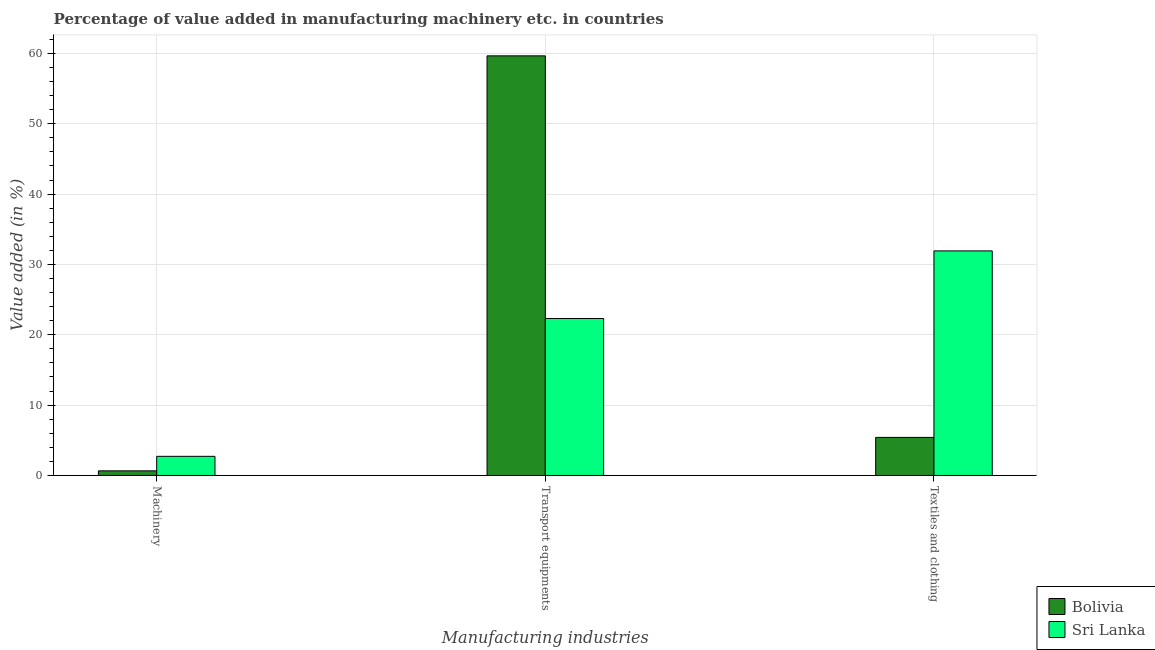How many groups of bars are there?
Your answer should be very brief. 3. Are the number of bars per tick equal to the number of legend labels?
Keep it short and to the point. Yes. How many bars are there on the 2nd tick from the left?
Your response must be concise. 2. What is the label of the 3rd group of bars from the left?
Give a very brief answer. Textiles and clothing. What is the value added in manufacturing transport equipments in Bolivia?
Provide a short and direct response. 59.66. Across all countries, what is the maximum value added in manufacturing transport equipments?
Ensure brevity in your answer.  59.66. Across all countries, what is the minimum value added in manufacturing textile and clothing?
Your answer should be compact. 5.41. In which country was the value added in manufacturing transport equipments minimum?
Offer a terse response. Sri Lanka. What is the total value added in manufacturing machinery in the graph?
Offer a very short reply. 3.37. What is the difference between the value added in manufacturing machinery in Sri Lanka and that in Bolivia?
Offer a terse response. 2.06. What is the difference between the value added in manufacturing transport equipments in Bolivia and the value added in manufacturing machinery in Sri Lanka?
Ensure brevity in your answer.  56.94. What is the average value added in manufacturing transport equipments per country?
Your response must be concise. 40.99. What is the difference between the value added in manufacturing textile and clothing and value added in manufacturing machinery in Bolivia?
Provide a succinct answer. 4.76. What is the ratio of the value added in manufacturing machinery in Bolivia to that in Sri Lanka?
Offer a terse response. 0.24. What is the difference between the highest and the second highest value added in manufacturing textile and clothing?
Give a very brief answer. 26.52. What is the difference between the highest and the lowest value added in manufacturing machinery?
Your response must be concise. 2.06. In how many countries, is the value added in manufacturing textile and clothing greater than the average value added in manufacturing textile and clothing taken over all countries?
Your answer should be compact. 1. What does the 1st bar from the left in Machinery represents?
Offer a terse response. Bolivia. What does the 1st bar from the right in Transport equipments represents?
Keep it short and to the point. Sri Lanka. How many bars are there?
Make the answer very short. 6. What is the difference between two consecutive major ticks on the Y-axis?
Ensure brevity in your answer.  10. Are the values on the major ticks of Y-axis written in scientific E-notation?
Provide a short and direct response. No. Does the graph contain grids?
Provide a short and direct response. Yes. How are the legend labels stacked?
Provide a succinct answer. Vertical. What is the title of the graph?
Your answer should be very brief. Percentage of value added in manufacturing machinery etc. in countries. Does "Israel" appear as one of the legend labels in the graph?
Keep it short and to the point. No. What is the label or title of the X-axis?
Offer a terse response. Manufacturing industries. What is the label or title of the Y-axis?
Offer a very short reply. Value added (in %). What is the Value added (in %) in Bolivia in Machinery?
Ensure brevity in your answer.  0.65. What is the Value added (in %) in Sri Lanka in Machinery?
Offer a terse response. 2.72. What is the Value added (in %) in Bolivia in Transport equipments?
Provide a short and direct response. 59.66. What is the Value added (in %) of Sri Lanka in Transport equipments?
Make the answer very short. 22.32. What is the Value added (in %) of Bolivia in Textiles and clothing?
Your answer should be very brief. 5.41. What is the Value added (in %) of Sri Lanka in Textiles and clothing?
Give a very brief answer. 31.93. Across all Manufacturing industries, what is the maximum Value added (in %) of Bolivia?
Provide a succinct answer. 59.66. Across all Manufacturing industries, what is the maximum Value added (in %) in Sri Lanka?
Offer a terse response. 31.93. Across all Manufacturing industries, what is the minimum Value added (in %) in Bolivia?
Give a very brief answer. 0.65. Across all Manufacturing industries, what is the minimum Value added (in %) of Sri Lanka?
Your answer should be compact. 2.72. What is the total Value added (in %) of Bolivia in the graph?
Offer a terse response. 65.72. What is the total Value added (in %) of Sri Lanka in the graph?
Keep it short and to the point. 56.96. What is the difference between the Value added (in %) of Bolivia in Machinery and that in Transport equipments?
Give a very brief answer. -59. What is the difference between the Value added (in %) of Sri Lanka in Machinery and that in Transport equipments?
Ensure brevity in your answer.  -19.6. What is the difference between the Value added (in %) in Bolivia in Machinery and that in Textiles and clothing?
Provide a succinct answer. -4.76. What is the difference between the Value added (in %) in Sri Lanka in Machinery and that in Textiles and clothing?
Provide a succinct answer. -29.21. What is the difference between the Value added (in %) in Bolivia in Transport equipments and that in Textiles and clothing?
Give a very brief answer. 54.25. What is the difference between the Value added (in %) in Sri Lanka in Transport equipments and that in Textiles and clothing?
Give a very brief answer. -9.61. What is the difference between the Value added (in %) in Bolivia in Machinery and the Value added (in %) in Sri Lanka in Transport equipments?
Your response must be concise. -21.66. What is the difference between the Value added (in %) of Bolivia in Machinery and the Value added (in %) of Sri Lanka in Textiles and clothing?
Offer a terse response. -31.27. What is the difference between the Value added (in %) in Bolivia in Transport equipments and the Value added (in %) in Sri Lanka in Textiles and clothing?
Your answer should be compact. 27.73. What is the average Value added (in %) of Bolivia per Manufacturing industries?
Give a very brief answer. 21.91. What is the average Value added (in %) in Sri Lanka per Manufacturing industries?
Your response must be concise. 18.99. What is the difference between the Value added (in %) in Bolivia and Value added (in %) in Sri Lanka in Machinery?
Make the answer very short. -2.06. What is the difference between the Value added (in %) in Bolivia and Value added (in %) in Sri Lanka in Transport equipments?
Offer a terse response. 37.34. What is the difference between the Value added (in %) of Bolivia and Value added (in %) of Sri Lanka in Textiles and clothing?
Ensure brevity in your answer.  -26.52. What is the ratio of the Value added (in %) in Bolivia in Machinery to that in Transport equipments?
Give a very brief answer. 0.01. What is the ratio of the Value added (in %) in Sri Lanka in Machinery to that in Transport equipments?
Your answer should be very brief. 0.12. What is the ratio of the Value added (in %) of Bolivia in Machinery to that in Textiles and clothing?
Your answer should be compact. 0.12. What is the ratio of the Value added (in %) of Sri Lanka in Machinery to that in Textiles and clothing?
Offer a terse response. 0.09. What is the ratio of the Value added (in %) of Bolivia in Transport equipments to that in Textiles and clothing?
Your answer should be very brief. 11.03. What is the ratio of the Value added (in %) of Sri Lanka in Transport equipments to that in Textiles and clothing?
Offer a terse response. 0.7. What is the difference between the highest and the second highest Value added (in %) in Bolivia?
Offer a terse response. 54.25. What is the difference between the highest and the second highest Value added (in %) of Sri Lanka?
Give a very brief answer. 9.61. What is the difference between the highest and the lowest Value added (in %) in Bolivia?
Make the answer very short. 59. What is the difference between the highest and the lowest Value added (in %) of Sri Lanka?
Keep it short and to the point. 29.21. 